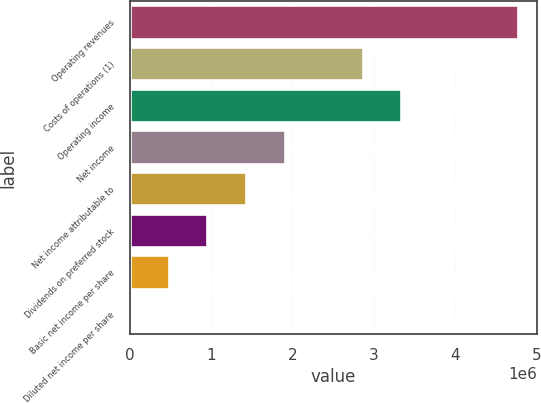<chart> <loc_0><loc_0><loc_500><loc_500><bar_chart><fcel>Operating revenues<fcel>Costs of operations (1)<fcel>Operating income<fcel>Net income<fcel>Net income attributable to<fcel>Dividends on preferred stock<fcel>Basic net income per share<fcel>Diluted net income per share<nl><fcel>4.77152e+06<fcel>2.86291e+06<fcel>3.34006e+06<fcel>1.90861e+06<fcel>1.43146e+06<fcel>954304<fcel>477153<fcel>1.41<nl></chart> 